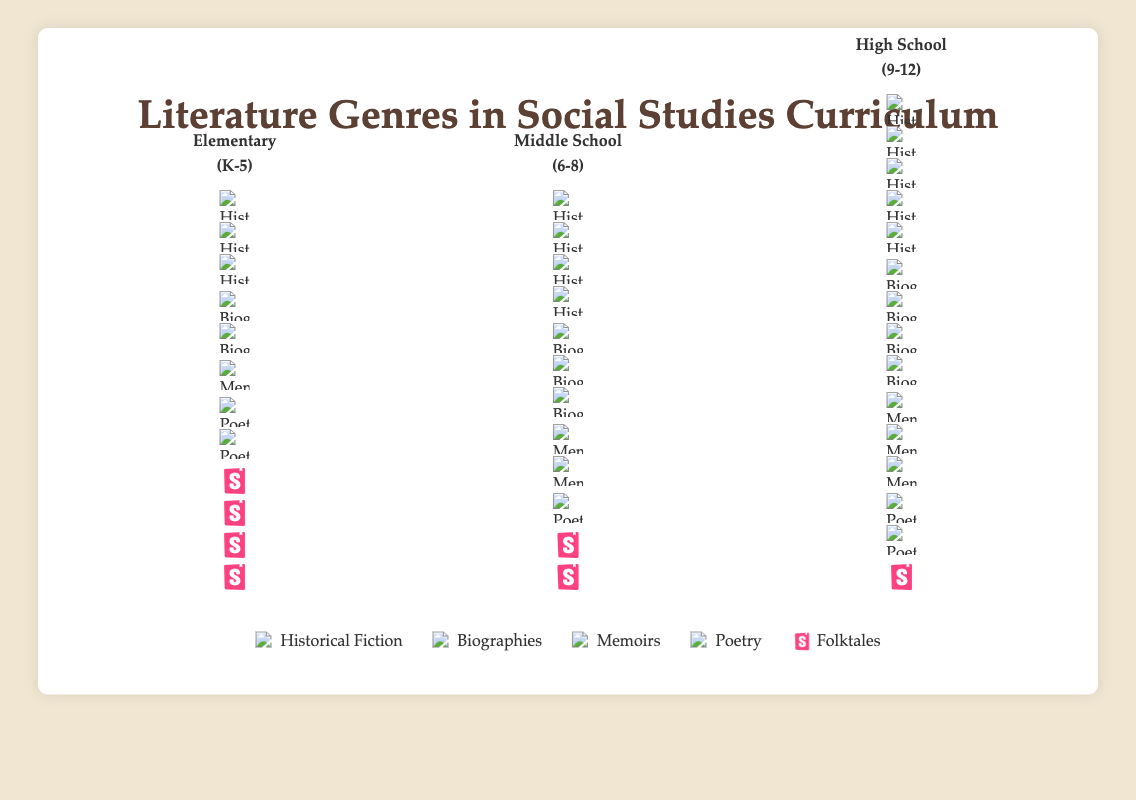What is the title of the figure? The title can be found at the top center of the figure and reads: "Literature Genres in Social Studies Curriculum".
Answer: Literature Genres in Social Studies Curriculum Which grade level has the highest number of Folktales? By observing the number of folktale icons in each grade level column, we see that Elementary (K-5) has the most with 4 folktale icons.
Answer: Elementary (K-5) How many genres are represented in the entire figure? By looking at the legend at the bottom of the figure, we can count the different genre items. There are 5 genres: Historical Fiction, Biographies, Memoirs, Poetry, and Folktales.
Answer: 5 Compare the number of Biography books used in Middle School and High School. Which one is higher and by how much? Middle School has 3 biography icons and High School has 4. The difference is 4 - 3 = 1, so High School has one more biography book than Middle School.
Answer: High School by 1 What is the total number of Historical Fiction books used across all grade levels? Adding the number of historical fiction icons from each grade level: 3 (Elementary) + 4 (Middle School) + 5 (High School) = 12.
Answer: 12 Which grade level has the least number of Poetry books? By counting the poetry icons in each grade level column, we find that Middle School has the least with just 1 poetry icon.
Answer: Middle School (6-8) Identify the grade level with the highest overall number of integrated literature genres and count them. To find this, we count all genre icons in each grade: Elementary (3+2+1+2+4)=12, Middle School (4+3+2+1+2)=12, High School (5+4+3+2+1)=15. High School has the highest with 15 icons.
Answer: High School (9-12) with 15 If we were to add two more Folktales to each grade level, how many Folktale icons would there be in total? Currently, the total number of Folktales across the grades is 4 (Elementary) + 2 (Middle School) + 1 (High School) = 7. Adding two to each gives us (4+2) + (2+2) + (1+2) = 10.
Answer: 10 How many more Historical Fiction books are there in High School compared to Elementary? High School has 5 historical fiction icons and Elementary has 3, so the difference is 5 - 3 = 2.
Answer: 2 What is the average number of Memoirs books per grade level? Adding the number of memoir icons in each grade gives us: 1 (Elementary) + 2 (Middle School) + 3 (High School) = 6. The average is 6 / 3 = 2.
Answer: 2 